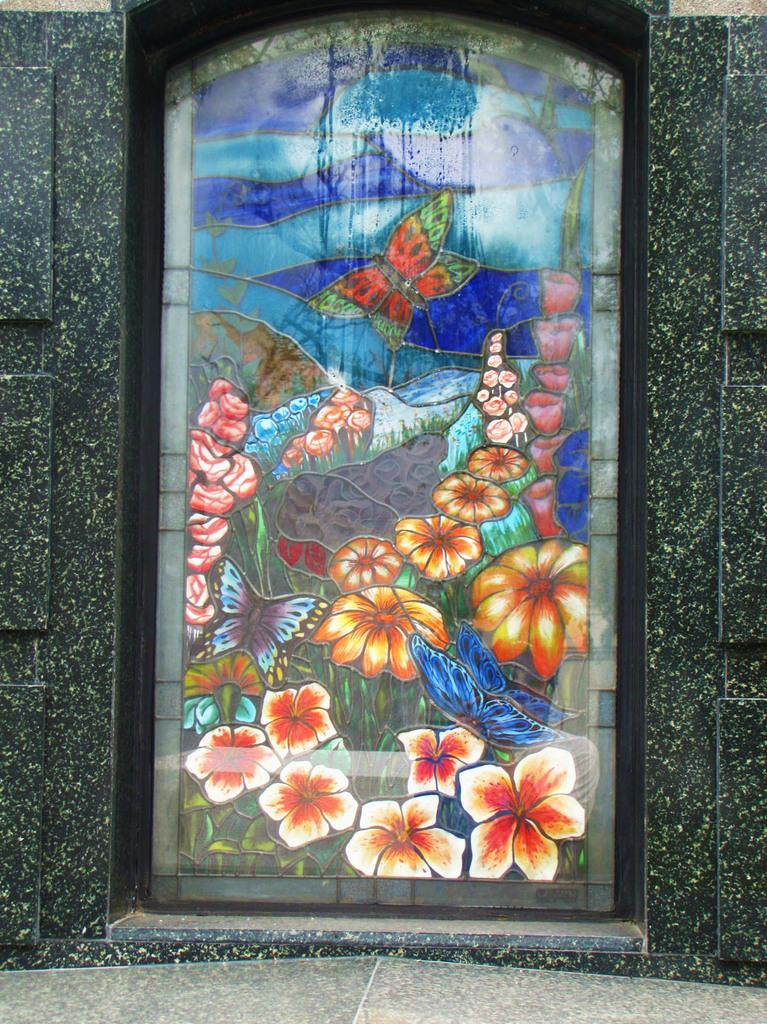What is the main subject in the image? There is a stained glass in the image. What type of mask is the laborer wearing while playing with the toy in the image? There is no laborer, mask, or toy present in the image; it only features a stained glass. 